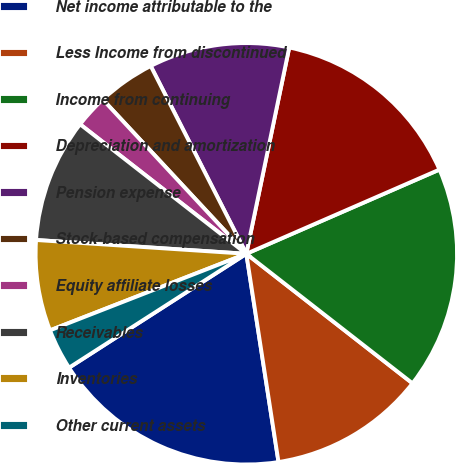<chart> <loc_0><loc_0><loc_500><loc_500><pie_chart><fcel>Net income attributable to the<fcel>Less Income from discontinued<fcel>Income from continuing<fcel>Depreciation and amortization<fcel>Pension expense<fcel>Stock-based compensation<fcel>Equity affiliate losses<fcel>Receivables<fcel>Inventories<fcel>Other current assets<nl><fcel>18.35%<fcel>12.02%<fcel>17.08%<fcel>15.19%<fcel>10.76%<fcel>4.43%<fcel>2.54%<fcel>9.49%<fcel>6.96%<fcel>3.17%<nl></chart> 